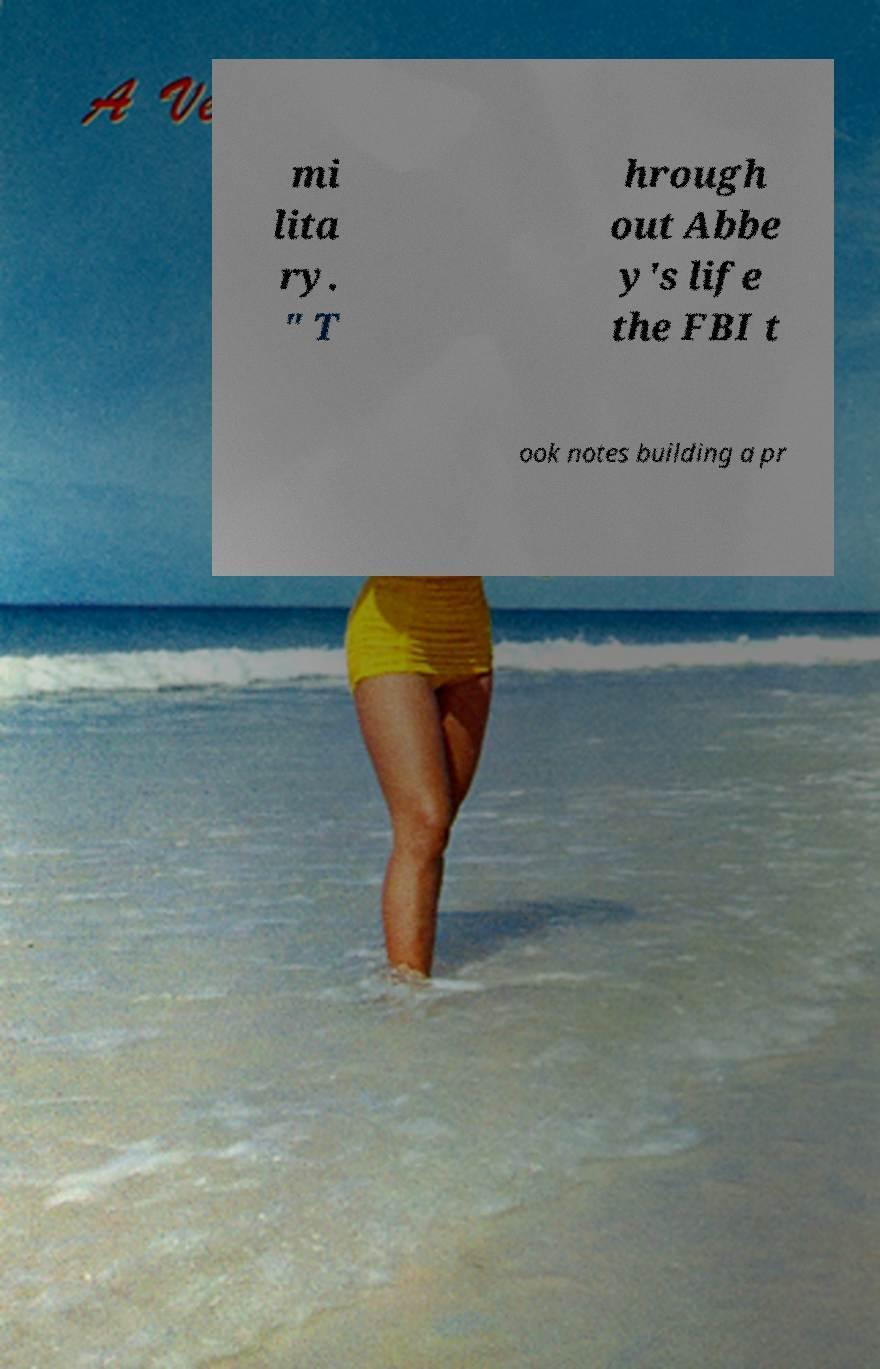Could you assist in decoding the text presented in this image and type it out clearly? mi lita ry. " T hrough out Abbe y's life the FBI t ook notes building a pr 